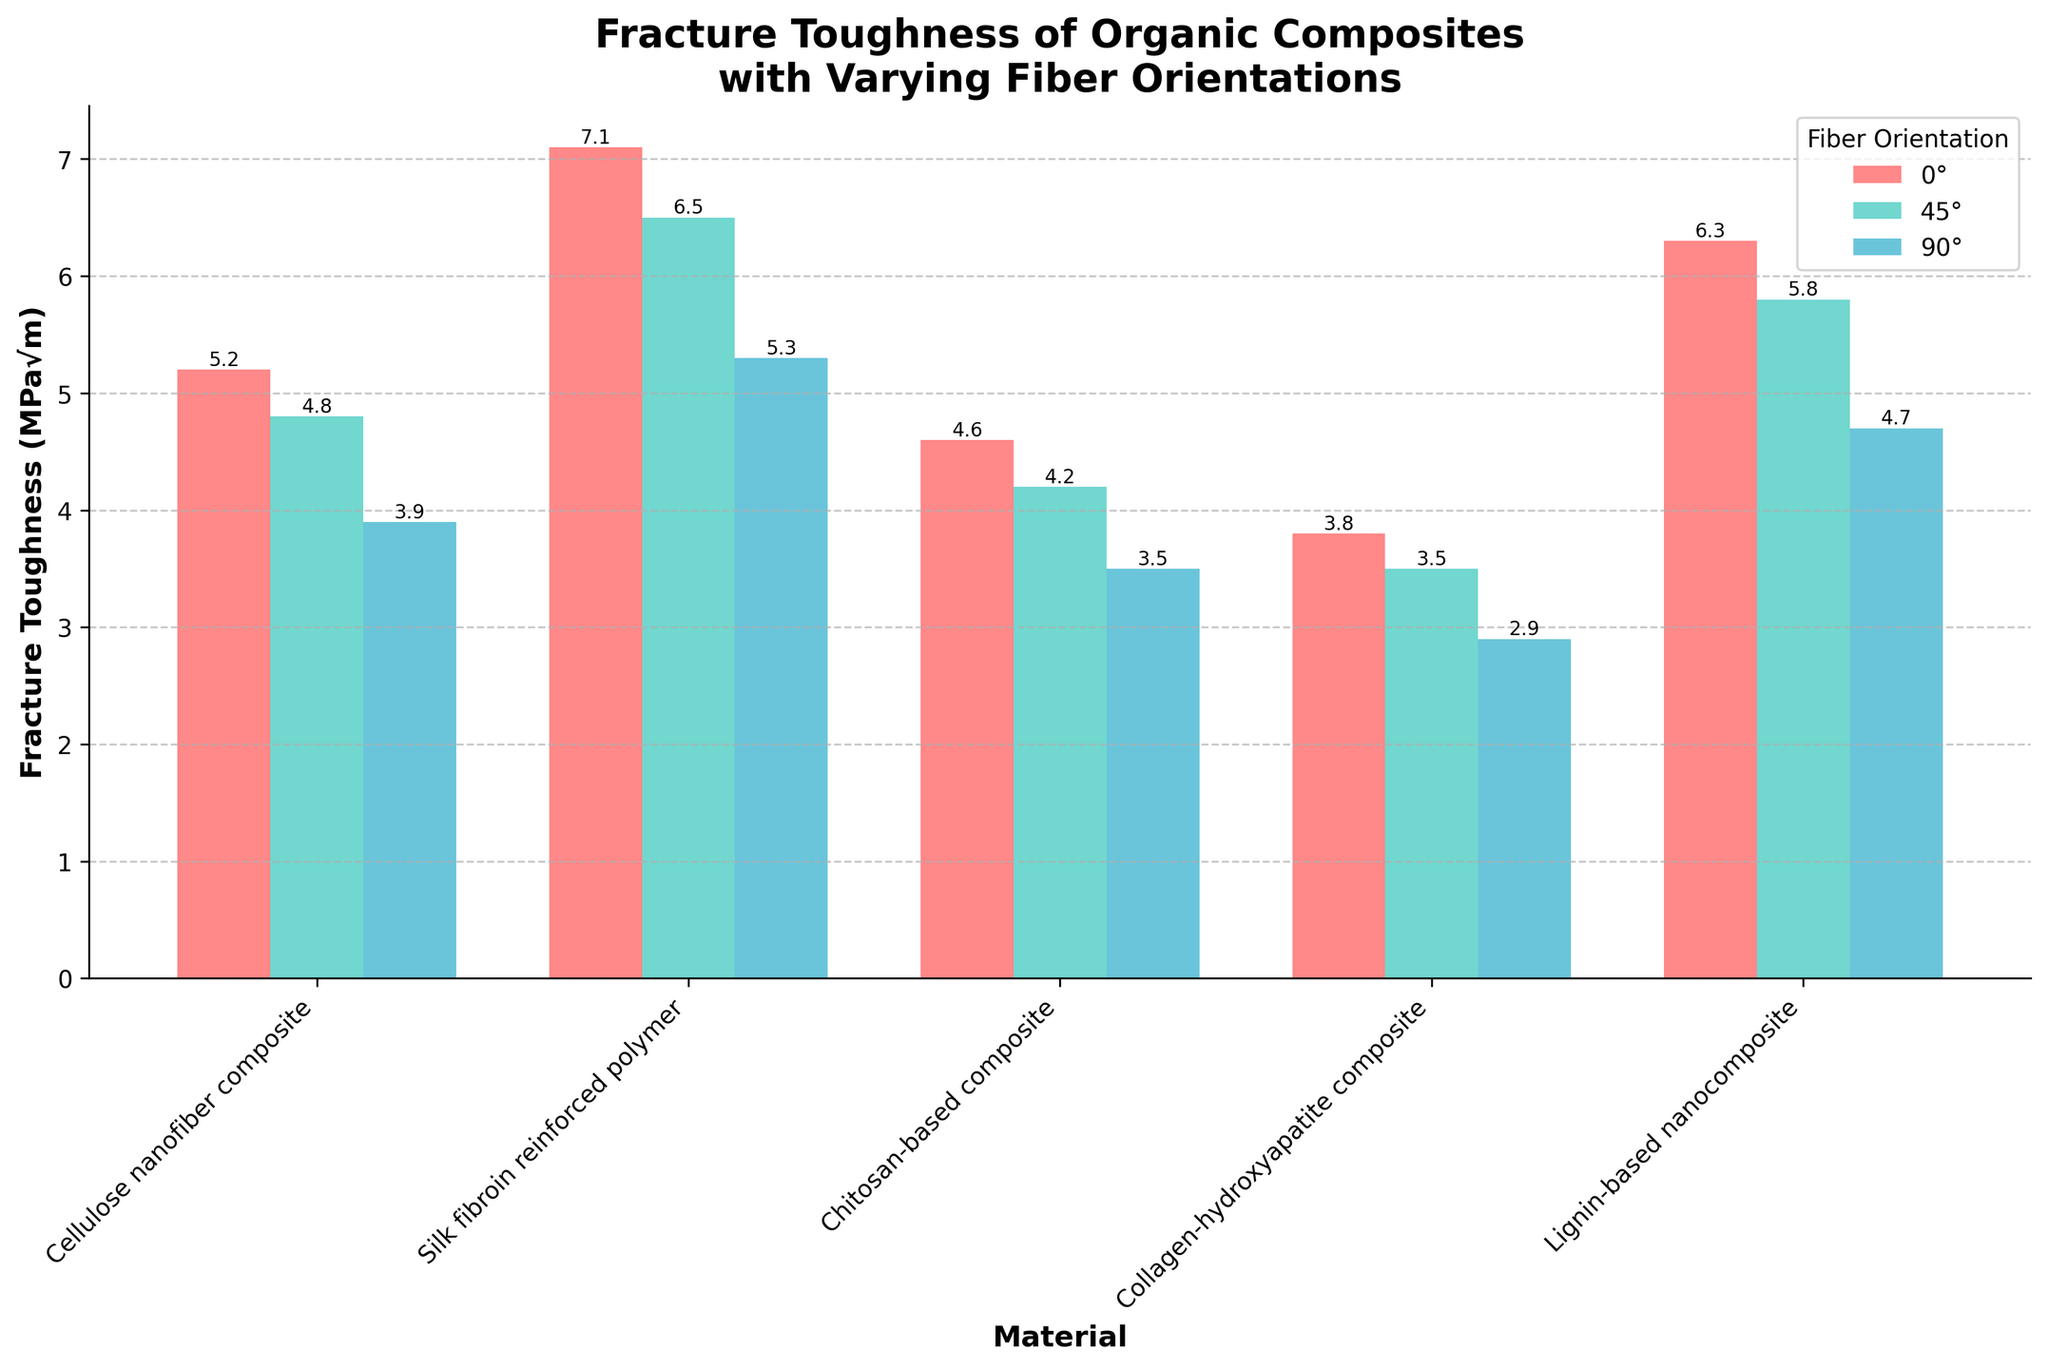What is the fracture toughness of the Silk fibroin reinforced polymer at a 90-degree fiber orientation? The bar corresponding to Silk fibroin reinforced polymer at 90 degrees has a height indicating a fracture toughness of 5.3 MPa√m.
Answer: 5.3 MPa√m What is the difference in fracture toughness between the 0-degree and 90-degree fiber orientations for the Lignin-based nanocomposite? The fracture toughness for the Lignin-based nanocomposite at 0 degrees is 6.3 MPa√m, and at 90 degrees, it is 4.7 MPa√m. The difference is 6.3 - 4.7 = 1.6 MPa√m.
Answer: 1.6 MPa√m Which material has the highest fracture toughness at a 45-degree fiber orientation? The bar showing the fracture toughness at 45 degrees for Silk fibroin reinforced polymer is the highest among other materials, indicating 6.5 MPa√m.
Answer: Silk fibroin reinforced polymer Is the fracture toughness of the Chitosan-based composite at a 0-degree fiber orientation greater than that of the Collagen-hydroxyapatite composite at the same orientation? The fracture toughness of the Chitosan-based composite at 0 degrees is 4.6 MPa√m, whereas for the Collagen-hydroxyapatite composite, it is 3.8 MPa√m. Since 4.6 is greater than 3.8, the answer is yes.
Answer: Yes What is the average fracture toughness of all materials at a 90-degree fiber orientation? The fracture toughness values at 90 degrees are 3.9, 5.3, 3.5, 2.9, and 4.7. The average is (3.9 + 5.3 + 3.5 + 2.9 + 4.7) / 5 = 4.06 MPa√m.
Answer: 4.06 MPa√m How much higher is the fracture toughness of Silk fibroin reinforced polymers at 0 degrees compared to Chitosan-based composites at 45 degrees? The fracture toughness of Silk fibroin reinforced polymers at 0 degrees is 7.1 MPa√m, and Chitosan-based composites at 45 degrees is 4.2 MPa√m. The difference is 7.1 - 4.2 = 2.9 MPa√m.
Answer: 2.9 MPa√m Which material shows the smallest reduction in fracture toughness when the fiber orientation changes from 0 degrees to 90 degrees? The difference in fracture toughness from 0 to 90 degrees is calculated for each material:
- Cellulose nanofiber composite: 5.2 - 3.9 = 1.3
- Silk fibroin reinforced polymer: 7.1 - 5.3 = 1.8
- Chitosan-based composite: 4.6 - 3.5 = 1.1
- Collagen-hydroxyapatite composite: 3.8 - 2.9 = 0.9
- Lignin-based nanocomposite: 6.3 - 4.7 = 1.6
Collagen-hydroxyapatite composite shows the smallest reduction of 0.9 MPa√m.
Answer: Collagen-hydroxyapatite composite 